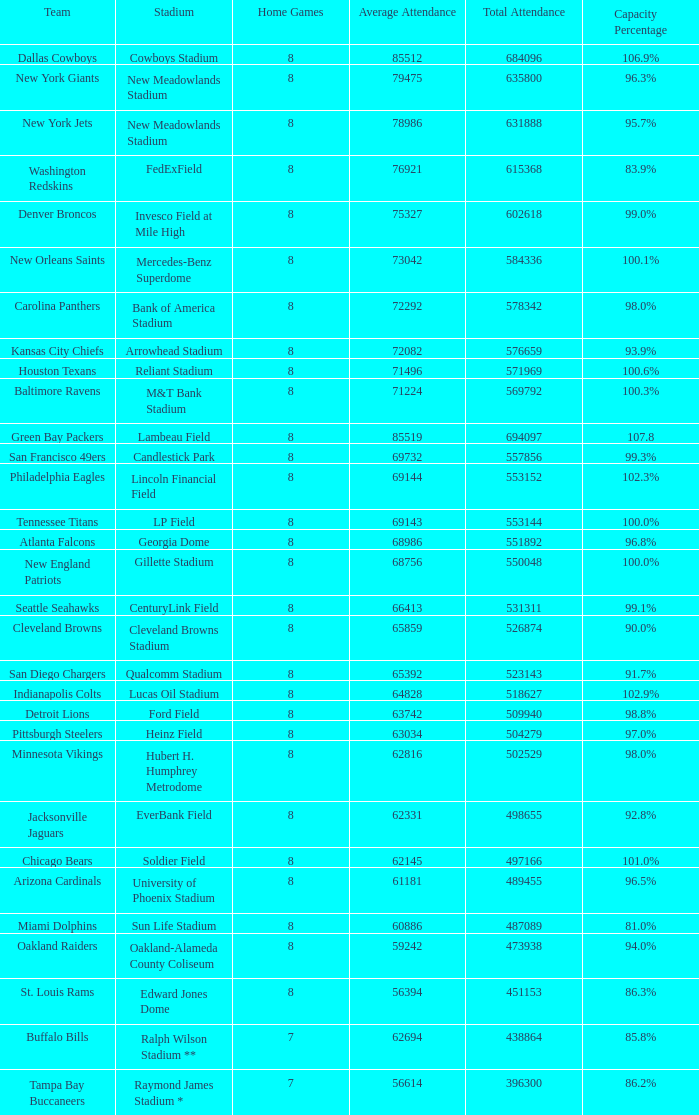What is the name of the stadium when the capacity percentage is 83.9% FedExField. 